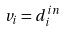<formula> <loc_0><loc_0><loc_500><loc_500>v _ { i } = d _ { i } ^ { i n }</formula> 